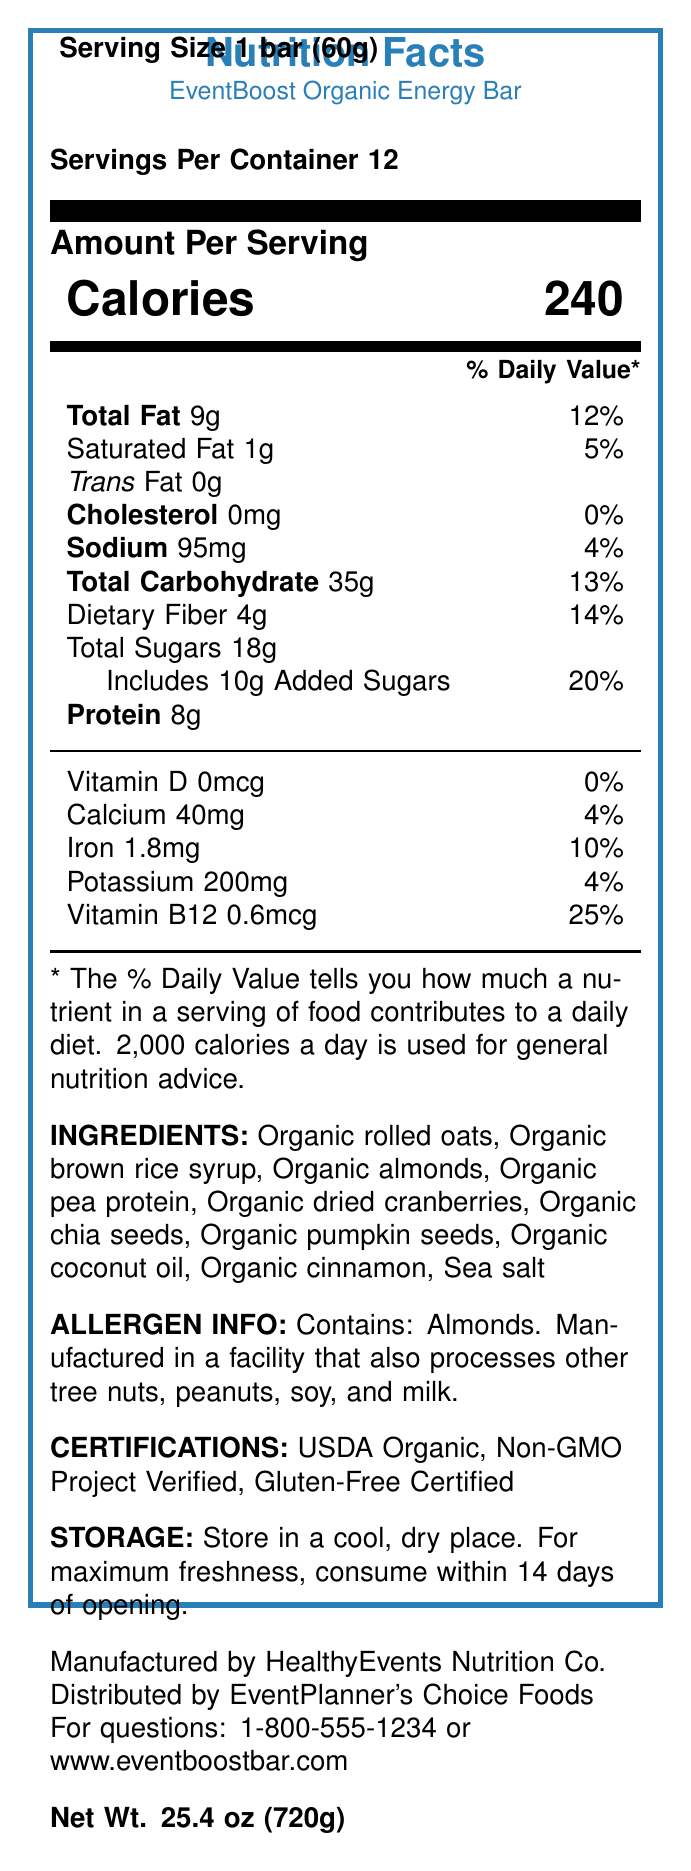what is the serving size of the EventBoost Organic Energy Bar? The serving size is clearly stated at the top of the document: "Serving Size 1 bar (60g)".
Answer: 1 bar (60g) how many calories are in one serving of the energy bar? The document lists the calorie content as "Calories 240" in a highlighted section.
Answer: 240 calories what is the total fat content per serving? The "Total Fat" content is listed as "9g" along with its daily value percentage (12%).
Answer: 9g what ingredients are included in the energy bar? The document lists the ingredients under the "INGREDIENTS" section.
Answer: Organic rolled oats, Organic brown rice syrup, Organic almonds, Organic pea protein, Organic dried cranberries, Organic chia seeds, Organic pumpkin seeds, Organic coconut oil, Organic cinnamon, Sea salt is Vitamin D present in the energy bar? The document shows "Vitamin D 0mcg" with a daily value of "0%", indicating that there is no Vitamin D.
Answer: No how should the energy bar be stored for maximum freshness? The "STORAGE" section provides these instructions for maintaining the bar's freshness.
Answer: Store in a cool, dry place and consume within 14 days of opening who manufactures the EventBoost Organic Energy Bar? The manufacturer is mentioned towards the bottom of the document: "Manufactured by HealthyEvents Nutrition Co."
Answer: HealthyEvents Nutrition Co. which nutrient contributes the highest percentage to the daily value? A. Protein B. Total Fat C. Vitamin B12 D. Iron Vitamin B12 has a daily value of 25%, which is the highest percentage among the listed nutrients.
Answer: C. Vitamin B12 what certifications does the energy bar have? A. USDA Organic, Non-GMO Project Verified B. Gluten-Free Certified, Non-GMO Project Verified C. USDA Organic, Non-GMO Project Verified, Gluten-Free Certified D. USDA Organic, Gluten-Free Certified, Low-Fat Certified The certifications are listed as "USDA Organic, Non-GMO Project Verified, Gluten-Free Certified".
Answer: C. USDA Organic, Non-GMO Project Verified, Gluten-Free Certified does the energy bar contain any allergens? The allergen information states: "Contains: Almonds. Manufactured in a facility that also processes other tree nuts, peanuts, soy, and milk."
Answer: Yes summarize the main information provided in the document. The document covers all aspects of nutrition, ingredients, and logistical information for the energy bar aimed at informing consumers.
Answer: The document provides detailed nutrition facts for the EventBoost Organic Energy Bar, including serving size, calorie count, nutrient amounts, ingredients, allergen information, storage instructions, certifications, and manufacturer contact details. how much total carbohydrates are in one serving? The "Total Carbohydrate" content is listed as "35g" along with its daily value percentage (13%).
Answer: 35g what percentage of the daily value does calcium constitute? The document lists Calcium with a daily value percentage of "4%".
Answer: 4% how many grams of dietary fiber are in one serving of the bar? The amount of "Dietary Fiber" per serving is specifically listed as "4g" with a daily value of "14%".
Answer: 4g what is the bar code for the EventBoost Organic Energy Bar? The bar code is clearly mentioned at the end of the document.
Answer: 890123456789 which nutrient has the lowest daily value percentage? The daily value for Vitamin D is "0%", which is the lowest percentage among the listed nutrients.
Answer: Vitamin D what is the impact of consuming more than one serving of the energy bar? The document only provides nutrition facts for a single serving; it does not specify the effects of consuming multiple servings.
Answer: Not enough information is the energy bar gluten-free? The "CERTIFICATIONS" section confirms that the energy bar is "Gluten-Free Certified".
Answer: Yes 